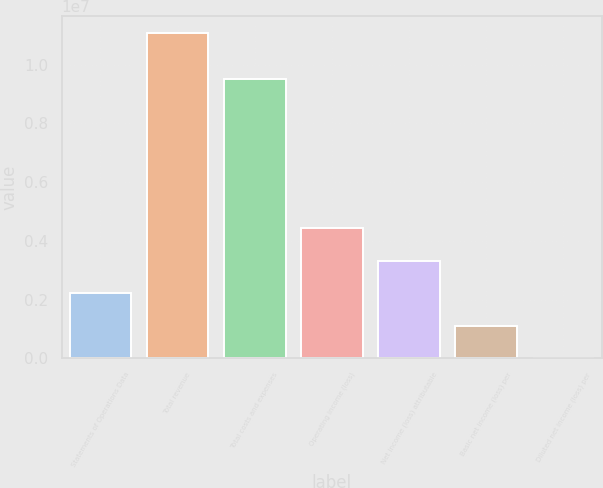Convert chart. <chart><loc_0><loc_0><loc_500><loc_500><bar_chart><fcel>Statements of Operations Data<fcel>Total revenue<fcel>Total costs and expenses<fcel>Operating income (loss)<fcel>Net income (loss) attributable<fcel>Basic net income (loss) per<fcel>Diluted net income (loss) per<nl><fcel>2.21808e+06<fcel>1.10904e+07<fcel>9.51697e+06<fcel>4.43615e+06<fcel>3.32711e+06<fcel>1.10904e+06<fcel>1.68<nl></chart> 